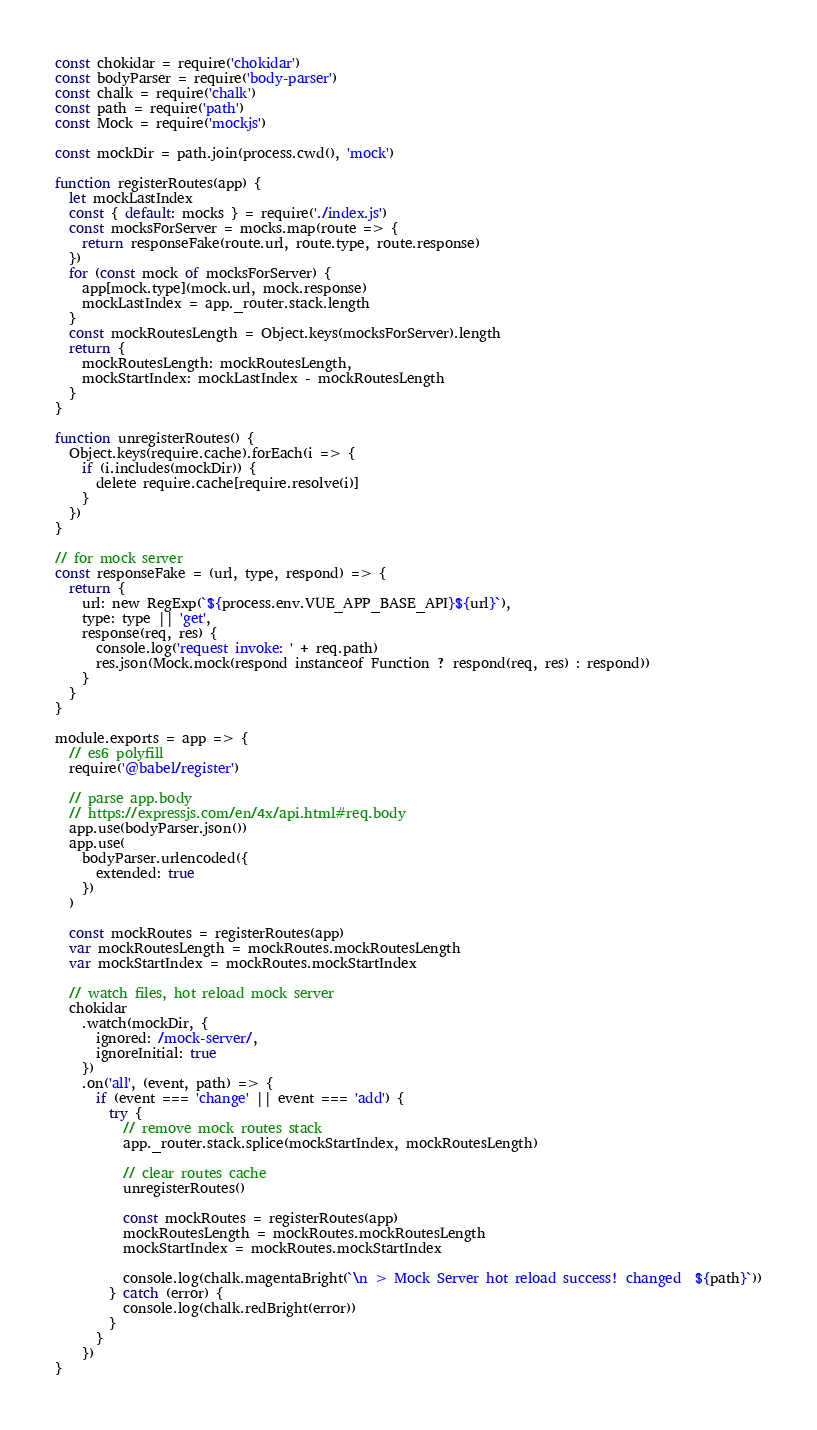Convert code to text. <code><loc_0><loc_0><loc_500><loc_500><_JavaScript_>const chokidar = require('chokidar')
const bodyParser = require('body-parser')
const chalk = require('chalk')
const path = require('path')
const Mock = require('mockjs')

const mockDir = path.join(process.cwd(), 'mock')

function registerRoutes(app) {
  let mockLastIndex
  const { default: mocks } = require('./index.js')
  const mocksForServer = mocks.map(route => {
    return responseFake(route.url, route.type, route.response)
  })
  for (const mock of mocksForServer) {
    app[mock.type](mock.url, mock.response)
    mockLastIndex = app._router.stack.length
  }
  const mockRoutesLength = Object.keys(mocksForServer).length
  return {
    mockRoutesLength: mockRoutesLength,
    mockStartIndex: mockLastIndex - mockRoutesLength
  }
}

function unregisterRoutes() {
  Object.keys(require.cache).forEach(i => {
    if (i.includes(mockDir)) {
      delete require.cache[require.resolve(i)]
    }
  })
}

// for mock server
const responseFake = (url, type, respond) => {
  return {
    url: new RegExp(`${process.env.VUE_APP_BASE_API}${url}`),
    type: type || 'get',
    response(req, res) {
      console.log('request invoke: ' + req.path)
      res.json(Mock.mock(respond instanceof Function ? respond(req, res) : respond))
    }
  }
}

module.exports = app => {
  // es6 polyfill
  require('@babel/register')

  // parse app.body
  // https://expressjs.com/en/4x/api.html#req.body
  app.use(bodyParser.json())
  app.use(
    bodyParser.urlencoded({
      extended: true
    })
  )

  const mockRoutes = registerRoutes(app)
  var mockRoutesLength = mockRoutes.mockRoutesLength
  var mockStartIndex = mockRoutes.mockStartIndex

  // watch files, hot reload mock server
  chokidar
    .watch(mockDir, {
      ignored: /mock-server/,
      ignoreInitial: true
    })
    .on('all', (event, path) => {
      if (event === 'change' || event === 'add') {
        try {
          // remove mock routes stack
          app._router.stack.splice(mockStartIndex, mockRoutesLength)

          // clear routes cache
          unregisterRoutes()

          const mockRoutes = registerRoutes(app)
          mockRoutesLength = mockRoutes.mockRoutesLength
          mockStartIndex = mockRoutes.mockStartIndex

          console.log(chalk.magentaBright(`\n > Mock Server hot reload success! changed  ${path}`))
        } catch (error) {
          console.log(chalk.redBright(error))
        }
      }
    })
}
</code> 